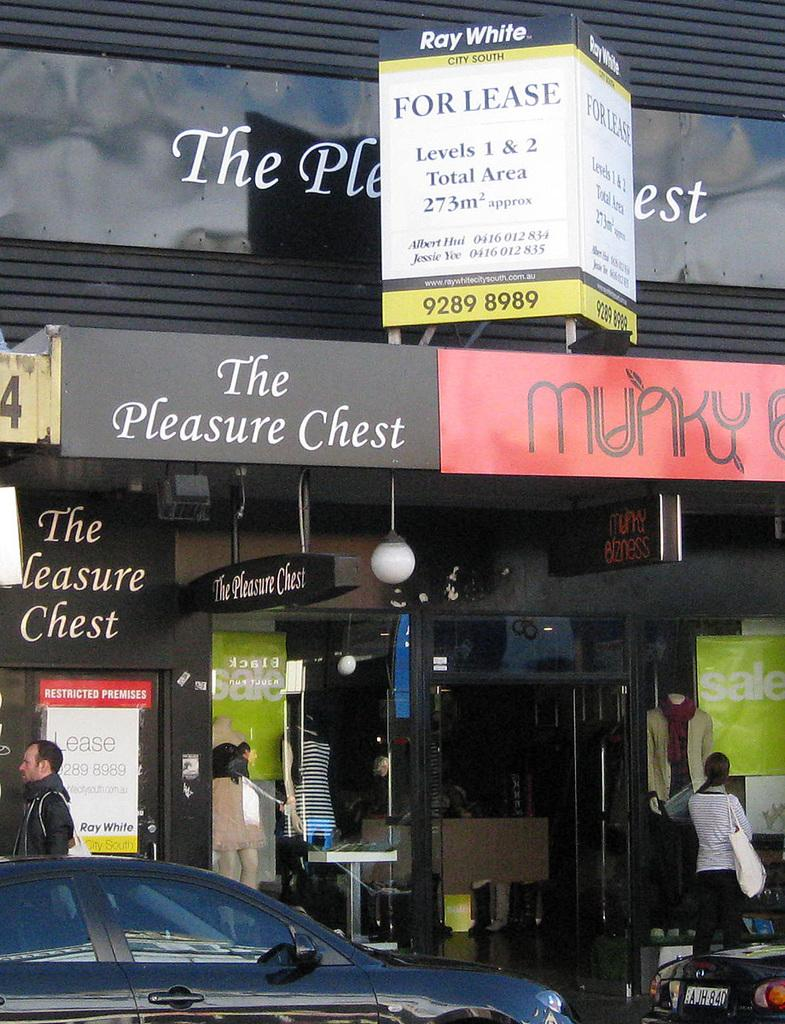What type of structures can be seen in the image? There are buildings in the image. Who or what else is present in the image? There are people and cars visible in the image. What type of signage is present in the image? Banners are present in the image. What type of government is depicted on the banner in the image? There is no indication of a specific government on the banner in the image. What wish is granted to the people in the image? There is no mention of a wish being granted in the image. 